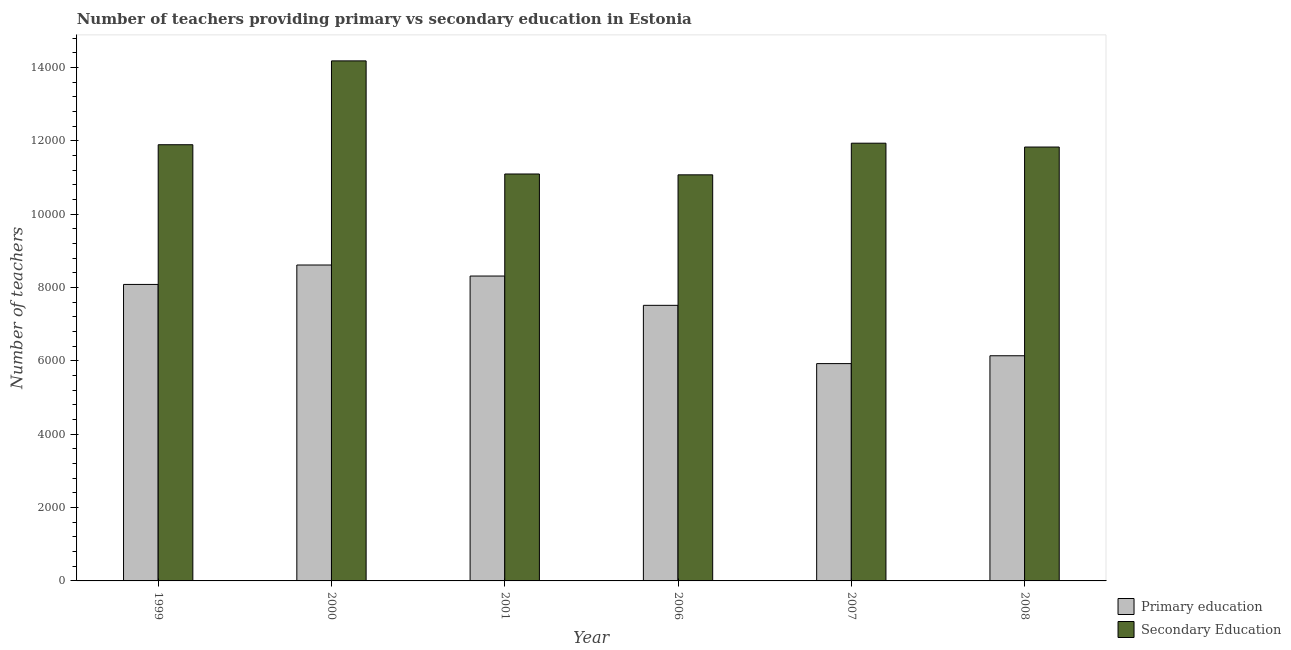How many different coloured bars are there?
Provide a succinct answer. 2. How many groups of bars are there?
Your answer should be compact. 6. Are the number of bars per tick equal to the number of legend labels?
Make the answer very short. Yes. Are the number of bars on each tick of the X-axis equal?
Offer a very short reply. Yes. In how many cases, is the number of bars for a given year not equal to the number of legend labels?
Give a very brief answer. 0. What is the number of primary teachers in 2001?
Your response must be concise. 8315. Across all years, what is the maximum number of secondary teachers?
Provide a short and direct response. 1.42e+04. Across all years, what is the minimum number of primary teachers?
Keep it short and to the point. 5927. In which year was the number of primary teachers maximum?
Make the answer very short. 2000. In which year was the number of secondary teachers minimum?
Ensure brevity in your answer.  2006. What is the total number of secondary teachers in the graph?
Your response must be concise. 7.20e+04. What is the difference between the number of secondary teachers in 2001 and that in 2008?
Your answer should be compact. -735. What is the difference between the number of secondary teachers in 2001 and the number of primary teachers in 2008?
Your response must be concise. -735. What is the average number of secondary teachers per year?
Give a very brief answer. 1.20e+04. What is the ratio of the number of secondary teachers in 2001 to that in 2007?
Your answer should be very brief. 0.93. Is the number of primary teachers in 2006 less than that in 2008?
Offer a terse response. No. Is the difference between the number of primary teachers in 1999 and 2008 greater than the difference between the number of secondary teachers in 1999 and 2008?
Provide a succinct answer. No. What is the difference between the highest and the second highest number of primary teachers?
Provide a succinct answer. 301. What is the difference between the highest and the lowest number of secondary teachers?
Your response must be concise. 3108. Is the sum of the number of secondary teachers in 1999 and 2000 greater than the maximum number of primary teachers across all years?
Your answer should be compact. Yes. What does the 2nd bar from the left in 2000 represents?
Your answer should be compact. Secondary Education. What does the 1st bar from the right in 2006 represents?
Offer a very short reply. Secondary Education. Are all the bars in the graph horizontal?
Offer a terse response. No. Does the graph contain grids?
Keep it short and to the point. No. Where does the legend appear in the graph?
Make the answer very short. Bottom right. How many legend labels are there?
Your response must be concise. 2. How are the legend labels stacked?
Provide a succinct answer. Vertical. What is the title of the graph?
Offer a terse response. Number of teachers providing primary vs secondary education in Estonia. What is the label or title of the Y-axis?
Offer a terse response. Number of teachers. What is the Number of teachers of Primary education in 1999?
Your answer should be compact. 8086. What is the Number of teachers in Secondary Education in 1999?
Offer a very short reply. 1.19e+04. What is the Number of teachers of Primary education in 2000?
Make the answer very short. 8616. What is the Number of teachers of Secondary Education in 2000?
Ensure brevity in your answer.  1.42e+04. What is the Number of teachers of Primary education in 2001?
Your answer should be compact. 8315. What is the Number of teachers of Secondary Education in 2001?
Make the answer very short. 1.11e+04. What is the Number of teachers in Primary education in 2006?
Your answer should be compact. 7516. What is the Number of teachers of Secondary Education in 2006?
Ensure brevity in your answer.  1.11e+04. What is the Number of teachers in Primary education in 2007?
Your response must be concise. 5927. What is the Number of teachers in Secondary Education in 2007?
Offer a very short reply. 1.19e+04. What is the Number of teachers of Primary education in 2008?
Provide a succinct answer. 6141. What is the Number of teachers in Secondary Education in 2008?
Provide a short and direct response. 1.18e+04. Across all years, what is the maximum Number of teachers in Primary education?
Ensure brevity in your answer.  8616. Across all years, what is the maximum Number of teachers of Secondary Education?
Make the answer very short. 1.42e+04. Across all years, what is the minimum Number of teachers in Primary education?
Your answer should be very brief. 5927. Across all years, what is the minimum Number of teachers in Secondary Education?
Your answer should be very brief. 1.11e+04. What is the total Number of teachers of Primary education in the graph?
Your answer should be very brief. 4.46e+04. What is the total Number of teachers in Secondary Education in the graph?
Provide a short and direct response. 7.20e+04. What is the difference between the Number of teachers of Primary education in 1999 and that in 2000?
Give a very brief answer. -530. What is the difference between the Number of teachers of Secondary Education in 1999 and that in 2000?
Make the answer very short. -2287. What is the difference between the Number of teachers in Primary education in 1999 and that in 2001?
Keep it short and to the point. -229. What is the difference between the Number of teachers in Secondary Education in 1999 and that in 2001?
Ensure brevity in your answer.  798. What is the difference between the Number of teachers in Primary education in 1999 and that in 2006?
Offer a terse response. 570. What is the difference between the Number of teachers in Secondary Education in 1999 and that in 2006?
Keep it short and to the point. 821. What is the difference between the Number of teachers of Primary education in 1999 and that in 2007?
Your answer should be compact. 2159. What is the difference between the Number of teachers in Secondary Education in 1999 and that in 2007?
Provide a succinct answer. -42. What is the difference between the Number of teachers in Primary education in 1999 and that in 2008?
Make the answer very short. 1945. What is the difference between the Number of teachers in Secondary Education in 1999 and that in 2008?
Your answer should be compact. 63. What is the difference between the Number of teachers in Primary education in 2000 and that in 2001?
Make the answer very short. 301. What is the difference between the Number of teachers in Secondary Education in 2000 and that in 2001?
Provide a short and direct response. 3085. What is the difference between the Number of teachers of Primary education in 2000 and that in 2006?
Your answer should be compact. 1100. What is the difference between the Number of teachers in Secondary Education in 2000 and that in 2006?
Your answer should be compact. 3108. What is the difference between the Number of teachers in Primary education in 2000 and that in 2007?
Keep it short and to the point. 2689. What is the difference between the Number of teachers of Secondary Education in 2000 and that in 2007?
Your answer should be very brief. 2245. What is the difference between the Number of teachers of Primary education in 2000 and that in 2008?
Provide a short and direct response. 2475. What is the difference between the Number of teachers in Secondary Education in 2000 and that in 2008?
Your answer should be compact. 2350. What is the difference between the Number of teachers of Primary education in 2001 and that in 2006?
Provide a short and direct response. 799. What is the difference between the Number of teachers of Secondary Education in 2001 and that in 2006?
Provide a short and direct response. 23. What is the difference between the Number of teachers in Primary education in 2001 and that in 2007?
Provide a succinct answer. 2388. What is the difference between the Number of teachers of Secondary Education in 2001 and that in 2007?
Keep it short and to the point. -840. What is the difference between the Number of teachers of Primary education in 2001 and that in 2008?
Provide a succinct answer. 2174. What is the difference between the Number of teachers in Secondary Education in 2001 and that in 2008?
Ensure brevity in your answer.  -735. What is the difference between the Number of teachers in Primary education in 2006 and that in 2007?
Provide a succinct answer. 1589. What is the difference between the Number of teachers of Secondary Education in 2006 and that in 2007?
Provide a short and direct response. -863. What is the difference between the Number of teachers in Primary education in 2006 and that in 2008?
Offer a very short reply. 1375. What is the difference between the Number of teachers of Secondary Education in 2006 and that in 2008?
Offer a very short reply. -758. What is the difference between the Number of teachers in Primary education in 2007 and that in 2008?
Your answer should be compact. -214. What is the difference between the Number of teachers of Secondary Education in 2007 and that in 2008?
Make the answer very short. 105. What is the difference between the Number of teachers in Primary education in 1999 and the Number of teachers in Secondary Education in 2000?
Keep it short and to the point. -6097. What is the difference between the Number of teachers in Primary education in 1999 and the Number of teachers in Secondary Education in 2001?
Offer a terse response. -3012. What is the difference between the Number of teachers of Primary education in 1999 and the Number of teachers of Secondary Education in 2006?
Offer a terse response. -2989. What is the difference between the Number of teachers in Primary education in 1999 and the Number of teachers in Secondary Education in 2007?
Give a very brief answer. -3852. What is the difference between the Number of teachers of Primary education in 1999 and the Number of teachers of Secondary Education in 2008?
Offer a terse response. -3747. What is the difference between the Number of teachers in Primary education in 2000 and the Number of teachers in Secondary Education in 2001?
Make the answer very short. -2482. What is the difference between the Number of teachers in Primary education in 2000 and the Number of teachers in Secondary Education in 2006?
Offer a very short reply. -2459. What is the difference between the Number of teachers in Primary education in 2000 and the Number of teachers in Secondary Education in 2007?
Provide a succinct answer. -3322. What is the difference between the Number of teachers in Primary education in 2000 and the Number of teachers in Secondary Education in 2008?
Provide a succinct answer. -3217. What is the difference between the Number of teachers of Primary education in 2001 and the Number of teachers of Secondary Education in 2006?
Ensure brevity in your answer.  -2760. What is the difference between the Number of teachers in Primary education in 2001 and the Number of teachers in Secondary Education in 2007?
Ensure brevity in your answer.  -3623. What is the difference between the Number of teachers of Primary education in 2001 and the Number of teachers of Secondary Education in 2008?
Your answer should be compact. -3518. What is the difference between the Number of teachers in Primary education in 2006 and the Number of teachers in Secondary Education in 2007?
Offer a terse response. -4422. What is the difference between the Number of teachers in Primary education in 2006 and the Number of teachers in Secondary Education in 2008?
Give a very brief answer. -4317. What is the difference between the Number of teachers of Primary education in 2007 and the Number of teachers of Secondary Education in 2008?
Keep it short and to the point. -5906. What is the average Number of teachers of Primary education per year?
Your answer should be very brief. 7433.5. What is the average Number of teachers of Secondary Education per year?
Ensure brevity in your answer.  1.20e+04. In the year 1999, what is the difference between the Number of teachers of Primary education and Number of teachers of Secondary Education?
Give a very brief answer. -3810. In the year 2000, what is the difference between the Number of teachers in Primary education and Number of teachers in Secondary Education?
Ensure brevity in your answer.  -5567. In the year 2001, what is the difference between the Number of teachers of Primary education and Number of teachers of Secondary Education?
Keep it short and to the point. -2783. In the year 2006, what is the difference between the Number of teachers in Primary education and Number of teachers in Secondary Education?
Make the answer very short. -3559. In the year 2007, what is the difference between the Number of teachers of Primary education and Number of teachers of Secondary Education?
Offer a terse response. -6011. In the year 2008, what is the difference between the Number of teachers in Primary education and Number of teachers in Secondary Education?
Provide a short and direct response. -5692. What is the ratio of the Number of teachers in Primary education in 1999 to that in 2000?
Ensure brevity in your answer.  0.94. What is the ratio of the Number of teachers of Secondary Education in 1999 to that in 2000?
Offer a terse response. 0.84. What is the ratio of the Number of teachers of Primary education in 1999 to that in 2001?
Make the answer very short. 0.97. What is the ratio of the Number of teachers of Secondary Education in 1999 to that in 2001?
Offer a very short reply. 1.07. What is the ratio of the Number of teachers of Primary education in 1999 to that in 2006?
Give a very brief answer. 1.08. What is the ratio of the Number of teachers of Secondary Education in 1999 to that in 2006?
Your response must be concise. 1.07. What is the ratio of the Number of teachers in Primary education in 1999 to that in 2007?
Ensure brevity in your answer.  1.36. What is the ratio of the Number of teachers of Primary education in 1999 to that in 2008?
Your answer should be very brief. 1.32. What is the ratio of the Number of teachers of Primary education in 2000 to that in 2001?
Offer a very short reply. 1.04. What is the ratio of the Number of teachers in Secondary Education in 2000 to that in 2001?
Offer a very short reply. 1.28. What is the ratio of the Number of teachers of Primary education in 2000 to that in 2006?
Make the answer very short. 1.15. What is the ratio of the Number of teachers in Secondary Education in 2000 to that in 2006?
Offer a very short reply. 1.28. What is the ratio of the Number of teachers in Primary education in 2000 to that in 2007?
Give a very brief answer. 1.45. What is the ratio of the Number of teachers of Secondary Education in 2000 to that in 2007?
Your answer should be compact. 1.19. What is the ratio of the Number of teachers of Primary education in 2000 to that in 2008?
Give a very brief answer. 1.4. What is the ratio of the Number of teachers in Secondary Education in 2000 to that in 2008?
Your answer should be very brief. 1.2. What is the ratio of the Number of teachers of Primary education in 2001 to that in 2006?
Offer a terse response. 1.11. What is the ratio of the Number of teachers in Primary education in 2001 to that in 2007?
Give a very brief answer. 1.4. What is the ratio of the Number of teachers of Secondary Education in 2001 to that in 2007?
Your answer should be very brief. 0.93. What is the ratio of the Number of teachers of Primary education in 2001 to that in 2008?
Your answer should be very brief. 1.35. What is the ratio of the Number of teachers in Secondary Education in 2001 to that in 2008?
Offer a very short reply. 0.94. What is the ratio of the Number of teachers in Primary education in 2006 to that in 2007?
Provide a short and direct response. 1.27. What is the ratio of the Number of teachers in Secondary Education in 2006 to that in 2007?
Keep it short and to the point. 0.93. What is the ratio of the Number of teachers in Primary education in 2006 to that in 2008?
Make the answer very short. 1.22. What is the ratio of the Number of teachers of Secondary Education in 2006 to that in 2008?
Provide a succinct answer. 0.94. What is the ratio of the Number of teachers in Primary education in 2007 to that in 2008?
Provide a succinct answer. 0.97. What is the ratio of the Number of teachers of Secondary Education in 2007 to that in 2008?
Keep it short and to the point. 1.01. What is the difference between the highest and the second highest Number of teachers in Primary education?
Give a very brief answer. 301. What is the difference between the highest and the second highest Number of teachers of Secondary Education?
Make the answer very short. 2245. What is the difference between the highest and the lowest Number of teachers of Primary education?
Give a very brief answer. 2689. What is the difference between the highest and the lowest Number of teachers of Secondary Education?
Your response must be concise. 3108. 